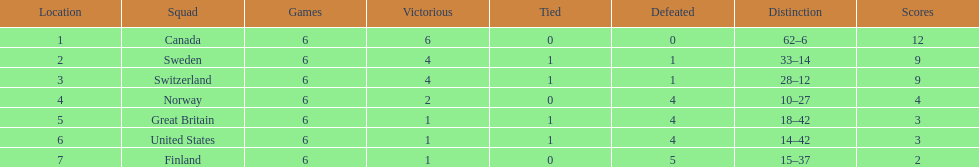Which country's team came in last place during the 1951 world ice hockey championships? Finland. 